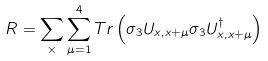<formula> <loc_0><loc_0><loc_500><loc_500>R = \sum _ { \times } \sum _ { \mu = 1 } ^ { 4 } T r \left ( \sigma _ { 3 } U _ { x , x + \mu } \sigma _ { 3 } U _ { x , x + \mu } ^ { \dagger } \right )</formula> 